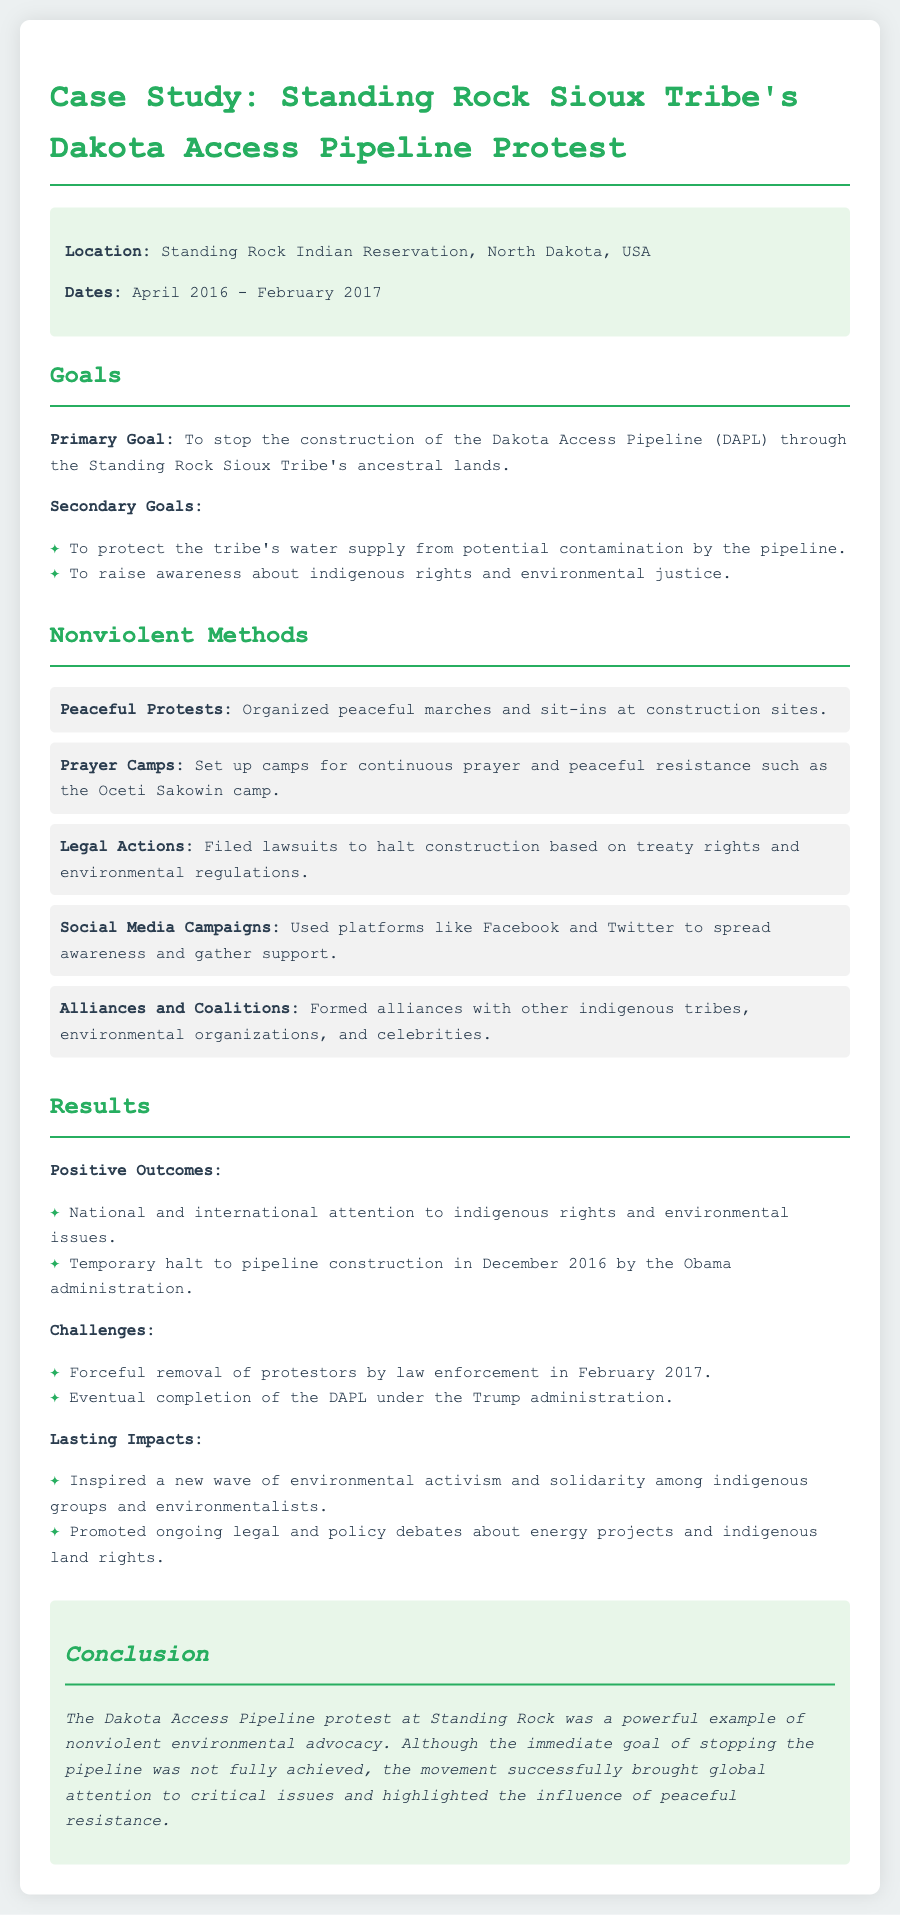What was the primary goal of the protest? The primary goal is explicitly stated in the document as stopping the construction of the Dakota Access Pipeline.
Answer: To stop the construction of the Dakota Access Pipeline What were the secondary goals? The document lists the secondary goals, including protecting the tribe's water supply and raising awareness about indigenous rights.
Answer: To protect the tribe's water supply from potential contamination by the pipeline; To raise awareness about indigenous rights and environmental justice In what timeframe did the events of the protest occur? The dates provided in the document span from April 2016 to February 2017.
Answer: April 2016 - February 2017 What method involved legal actions? The document mentions 'Legal Actions' specifically as a nonviolent method used during the protest.
Answer: Legal Actions What significant outcome occurred in December 2016? The document states that there was a temporary halt to the pipeline construction in December 2016.
Answer: Temporary halt to pipeline construction What was one of the challenges faced by the protestors? The document mentions the forceful removal of protestors by law enforcement in February 2017 as a challenge.
Answer: Forceful removal of protestors by law enforcement What overall impact did the protest have on indigenous activism? The lasting impacts section discusses inspiring a new wave of environmental activism among indigenous groups.
Answer: Inspired a new wave of environmental activism and solidarity among indigenous groups and environmentalists What camp was set up for prayer and peaceful resistance? The prayer camps section refers to the Oceti Sakowin camp as a notable example.
Answer: Oceti Sakowin camp 